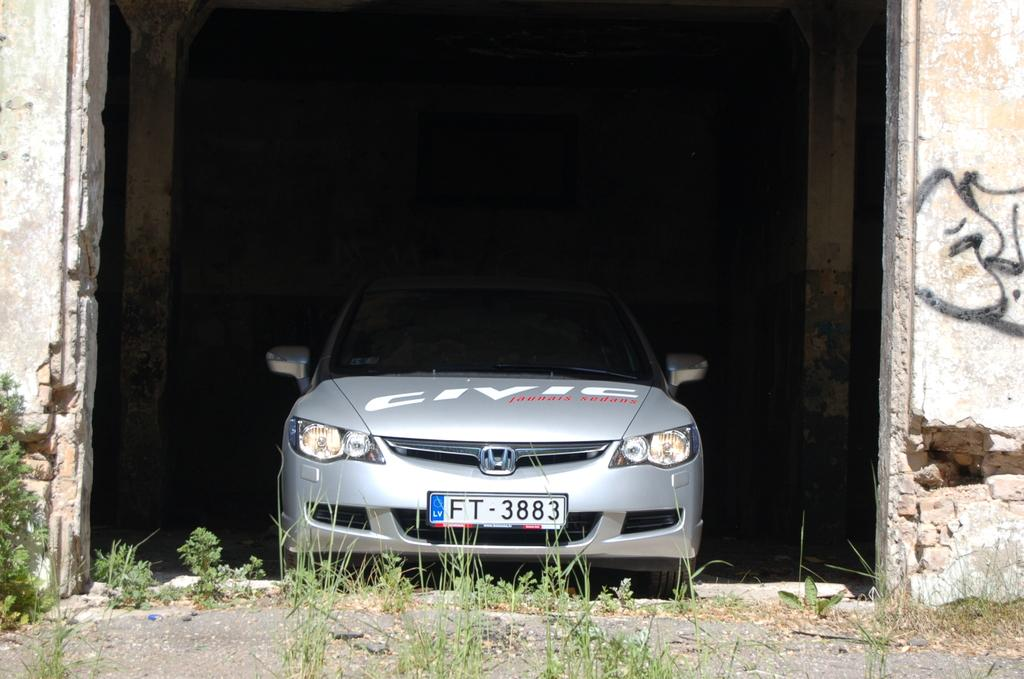What type of structure is visible in the image? There is a building in the image. What can be found inside the building? There is a vehicle in the building. What type of natural environment is visible at the bottom of the image? There is grass at the bottom of the image. How many fingers can be seen on the bed in the image? There is no bed or fingers present in the image. 